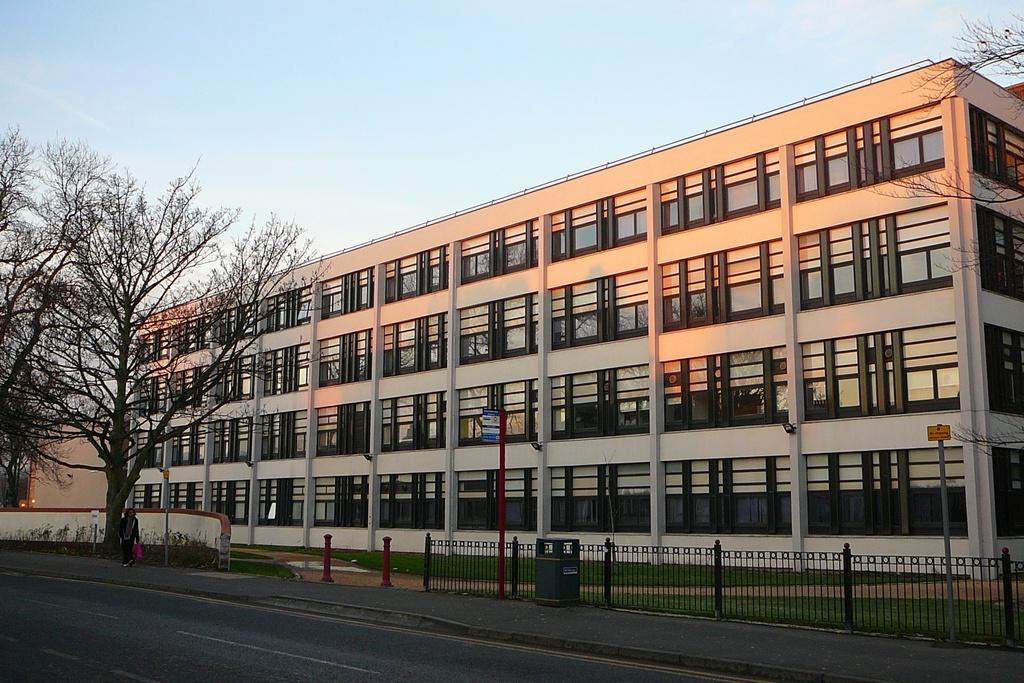How would you summarize this image in a sentence or two? In the image there is a building in the back with many windows and there is a road in front of it and a person walking on the footpath beside a tree and above its sky. 